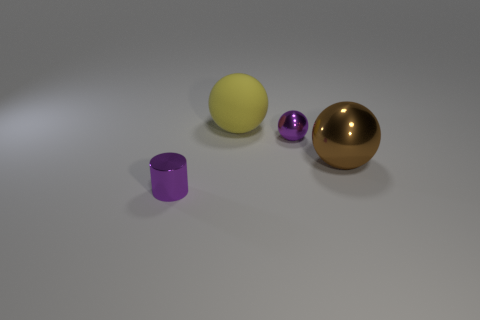What material is the tiny cylinder that is the same color as the tiny ball? The tiny cylinder appears to be made of a similar material to the tiny ball - possibly a polished or matte plastic - based on its color and light reflection characteristics. 